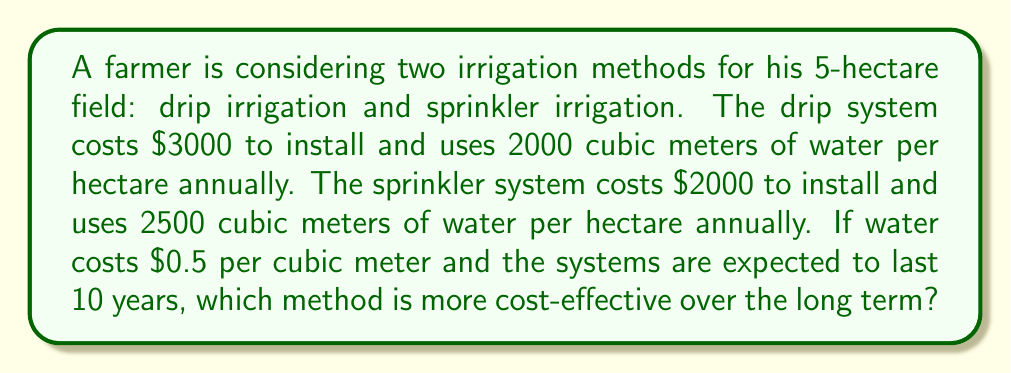Show me your answer to this math problem. Let's calculate the total cost for each system over 10 years:

1. Drip irrigation:
   - Installation cost: $3000
   - Annual water usage: $2000 \text{ m}^3/\text{ha} \times 5 \text{ ha} = 10000 \text{ m}^3$
   - Annual water cost: $10000 \text{ m}^3 \times \$0.5/\text{m}^3 = \$5000$
   - Total cost over 10 years: $\$3000 + (10 \times \$5000) = \$53000$

2. Sprinkler irrigation:
   - Installation cost: $2000
   - Annual water usage: $2500 \text{ m}^3/\text{ha} \times 5 \text{ ha} = 12500 \text{ m}^3$
   - Annual water cost: $12500 \text{ m}^3 \times \$0.5/\text{m}^3 = \$6250$
   - Total cost over 10 years: $\$2000 + (10 \times \$6250) = \$64500$

3. Comparison:
   - Drip irrigation total cost: $53000
   - Sprinkler irrigation total cost: $64500
   - Difference: $\$64500 - \$53000 = \$11500$

The drip irrigation system is $11500 less expensive over 10 years, making it more cost-effective in the long term.
Answer: Drip irrigation 